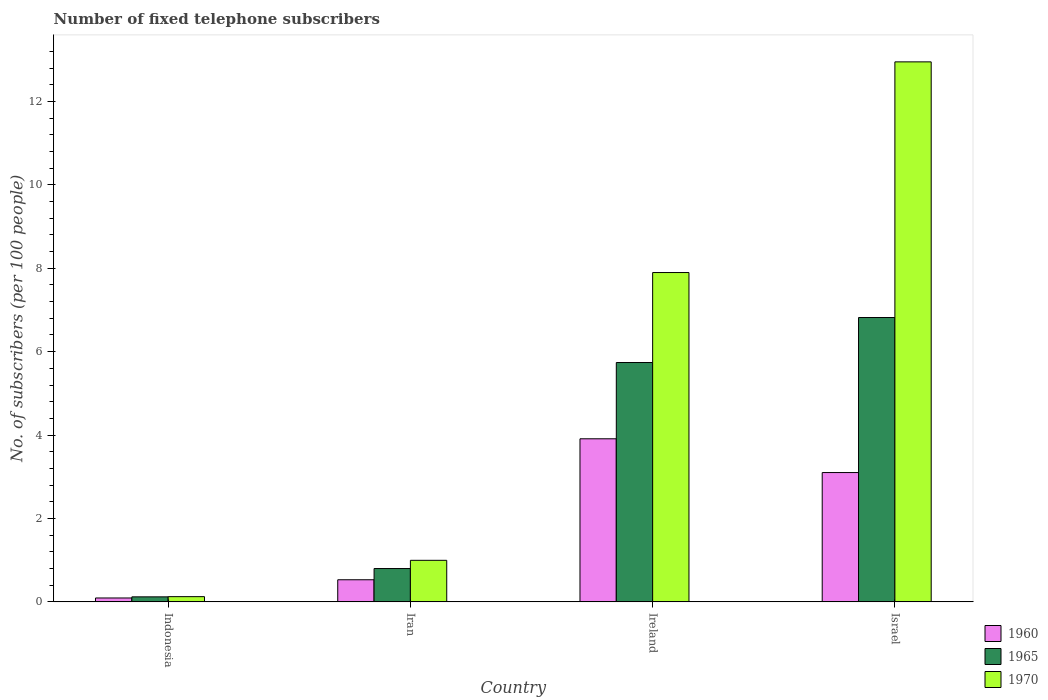How many groups of bars are there?
Provide a succinct answer. 4. How many bars are there on the 1st tick from the right?
Your answer should be very brief. 3. What is the label of the 3rd group of bars from the left?
Provide a succinct answer. Ireland. In how many cases, is the number of bars for a given country not equal to the number of legend labels?
Your answer should be very brief. 0. What is the number of fixed telephone subscribers in 1960 in Iran?
Your response must be concise. 0.53. Across all countries, what is the maximum number of fixed telephone subscribers in 1965?
Your answer should be compact. 6.82. Across all countries, what is the minimum number of fixed telephone subscribers in 1965?
Your answer should be compact. 0.12. In which country was the number of fixed telephone subscribers in 1960 maximum?
Offer a very short reply. Ireland. In which country was the number of fixed telephone subscribers in 1960 minimum?
Your response must be concise. Indonesia. What is the total number of fixed telephone subscribers in 1970 in the graph?
Your response must be concise. 21.97. What is the difference between the number of fixed telephone subscribers in 1960 in Indonesia and that in Iran?
Your answer should be very brief. -0.44. What is the difference between the number of fixed telephone subscribers in 1970 in Ireland and the number of fixed telephone subscribers in 1960 in Israel?
Your answer should be compact. 4.8. What is the average number of fixed telephone subscribers in 1960 per country?
Your answer should be compact. 1.91. What is the difference between the number of fixed telephone subscribers of/in 1960 and number of fixed telephone subscribers of/in 1970 in Iran?
Ensure brevity in your answer.  -0.47. In how many countries, is the number of fixed telephone subscribers in 1960 greater than 2?
Your answer should be very brief. 2. What is the ratio of the number of fixed telephone subscribers in 1960 in Ireland to that in Israel?
Give a very brief answer. 1.26. Is the number of fixed telephone subscribers in 1970 in Indonesia less than that in Israel?
Your answer should be compact. Yes. What is the difference between the highest and the second highest number of fixed telephone subscribers in 1965?
Keep it short and to the point. -4.94. What is the difference between the highest and the lowest number of fixed telephone subscribers in 1965?
Your answer should be very brief. 6.7. Is the sum of the number of fixed telephone subscribers in 1970 in Iran and Israel greater than the maximum number of fixed telephone subscribers in 1960 across all countries?
Your answer should be compact. Yes. What does the 1st bar from the left in Israel represents?
Keep it short and to the point. 1960. How many bars are there?
Your answer should be very brief. 12. How many countries are there in the graph?
Offer a terse response. 4. What is the difference between two consecutive major ticks on the Y-axis?
Ensure brevity in your answer.  2. Are the values on the major ticks of Y-axis written in scientific E-notation?
Give a very brief answer. No. Does the graph contain any zero values?
Give a very brief answer. No. Does the graph contain grids?
Give a very brief answer. No. Where does the legend appear in the graph?
Your answer should be very brief. Bottom right. How many legend labels are there?
Offer a terse response. 3. How are the legend labels stacked?
Provide a short and direct response. Vertical. What is the title of the graph?
Provide a short and direct response. Number of fixed telephone subscribers. What is the label or title of the X-axis?
Offer a terse response. Country. What is the label or title of the Y-axis?
Provide a succinct answer. No. of subscribers (per 100 people). What is the No. of subscribers (per 100 people) of 1960 in Indonesia?
Offer a terse response. 0.09. What is the No. of subscribers (per 100 people) in 1965 in Indonesia?
Your response must be concise. 0.12. What is the No. of subscribers (per 100 people) in 1970 in Indonesia?
Give a very brief answer. 0.13. What is the No. of subscribers (per 100 people) in 1960 in Iran?
Your answer should be compact. 0.53. What is the No. of subscribers (per 100 people) in 1965 in Iran?
Your response must be concise. 0.8. What is the No. of subscribers (per 100 people) of 1970 in Iran?
Offer a very short reply. 1. What is the No. of subscribers (per 100 people) in 1960 in Ireland?
Your response must be concise. 3.91. What is the No. of subscribers (per 100 people) of 1965 in Ireland?
Make the answer very short. 5.74. What is the No. of subscribers (per 100 people) in 1970 in Ireland?
Provide a succinct answer. 7.9. What is the No. of subscribers (per 100 people) in 1960 in Israel?
Ensure brevity in your answer.  3.1. What is the No. of subscribers (per 100 people) of 1965 in Israel?
Ensure brevity in your answer.  6.82. What is the No. of subscribers (per 100 people) in 1970 in Israel?
Make the answer very short. 12.95. Across all countries, what is the maximum No. of subscribers (per 100 people) of 1960?
Provide a short and direct response. 3.91. Across all countries, what is the maximum No. of subscribers (per 100 people) of 1965?
Give a very brief answer. 6.82. Across all countries, what is the maximum No. of subscribers (per 100 people) of 1970?
Your answer should be compact. 12.95. Across all countries, what is the minimum No. of subscribers (per 100 people) in 1960?
Provide a succinct answer. 0.09. Across all countries, what is the minimum No. of subscribers (per 100 people) of 1965?
Keep it short and to the point. 0.12. Across all countries, what is the minimum No. of subscribers (per 100 people) in 1970?
Make the answer very short. 0.13. What is the total No. of subscribers (per 100 people) in 1960 in the graph?
Keep it short and to the point. 7.64. What is the total No. of subscribers (per 100 people) in 1965 in the graph?
Give a very brief answer. 13.48. What is the total No. of subscribers (per 100 people) of 1970 in the graph?
Offer a terse response. 21.97. What is the difference between the No. of subscribers (per 100 people) in 1960 in Indonesia and that in Iran?
Ensure brevity in your answer.  -0.44. What is the difference between the No. of subscribers (per 100 people) of 1965 in Indonesia and that in Iran?
Provide a short and direct response. -0.68. What is the difference between the No. of subscribers (per 100 people) in 1970 in Indonesia and that in Iran?
Offer a terse response. -0.87. What is the difference between the No. of subscribers (per 100 people) of 1960 in Indonesia and that in Ireland?
Provide a short and direct response. -3.82. What is the difference between the No. of subscribers (per 100 people) in 1965 in Indonesia and that in Ireland?
Keep it short and to the point. -5.62. What is the difference between the No. of subscribers (per 100 people) in 1970 in Indonesia and that in Ireland?
Ensure brevity in your answer.  -7.77. What is the difference between the No. of subscribers (per 100 people) in 1960 in Indonesia and that in Israel?
Provide a short and direct response. -3.01. What is the difference between the No. of subscribers (per 100 people) in 1965 in Indonesia and that in Israel?
Your response must be concise. -6.7. What is the difference between the No. of subscribers (per 100 people) of 1970 in Indonesia and that in Israel?
Offer a very short reply. -12.82. What is the difference between the No. of subscribers (per 100 people) in 1960 in Iran and that in Ireland?
Your response must be concise. -3.38. What is the difference between the No. of subscribers (per 100 people) in 1965 in Iran and that in Ireland?
Provide a short and direct response. -4.94. What is the difference between the No. of subscribers (per 100 people) of 1970 in Iran and that in Ireland?
Keep it short and to the point. -6.9. What is the difference between the No. of subscribers (per 100 people) of 1960 in Iran and that in Israel?
Provide a short and direct response. -2.57. What is the difference between the No. of subscribers (per 100 people) in 1965 in Iran and that in Israel?
Provide a short and direct response. -6.02. What is the difference between the No. of subscribers (per 100 people) of 1970 in Iran and that in Israel?
Your answer should be very brief. -11.95. What is the difference between the No. of subscribers (per 100 people) in 1960 in Ireland and that in Israel?
Provide a short and direct response. 0.81. What is the difference between the No. of subscribers (per 100 people) in 1965 in Ireland and that in Israel?
Your answer should be very brief. -1.08. What is the difference between the No. of subscribers (per 100 people) in 1970 in Ireland and that in Israel?
Your response must be concise. -5.05. What is the difference between the No. of subscribers (per 100 people) in 1960 in Indonesia and the No. of subscribers (per 100 people) in 1965 in Iran?
Your answer should be very brief. -0.71. What is the difference between the No. of subscribers (per 100 people) in 1960 in Indonesia and the No. of subscribers (per 100 people) in 1970 in Iran?
Provide a succinct answer. -0.9. What is the difference between the No. of subscribers (per 100 people) in 1965 in Indonesia and the No. of subscribers (per 100 people) in 1970 in Iran?
Provide a short and direct response. -0.88. What is the difference between the No. of subscribers (per 100 people) of 1960 in Indonesia and the No. of subscribers (per 100 people) of 1965 in Ireland?
Offer a very short reply. -5.65. What is the difference between the No. of subscribers (per 100 people) of 1960 in Indonesia and the No. of subscribers (per 100 people) of 1970 in Ireland?
Make the answer very short. -7.8. What is the difference between the No. of subscribers (per 100 people) of 1965 in Indonesia and the No. of subscribers (per 100 people) of 1970 in Ireland?
Provide a succinct answer. -7.78. What is the difference between the No. of subscribers (per 100 people) of 1960 in Indonesia and the No. of subscribers (per 100 people) of 1965 in Israel?
Give a very brief answer. -6.73. What is the difference between the No. of subscribers (per 100 people) of 1960 in Indonesia and the No. of subscribers (per 100 people) of 1970 in Israel?
Your answer should be compact. -12.86. What is the difference between the No. of subscribers (per 100 people) of 1965 in Indonesia and the No. of subscribers (per 100 people) of 1970 in Israel?
Your response must be concise. -12.83. What is the difference between the No. of subscribers (per 100 people) in 1960 in Iran and the No. of subscribers (per 100 people) in 1965 in Ireland?
Your answer should be very brief. -5.21. What is the difference between the No. of subscribers (per 100 people) of 1960 in Iran and the No. of subscribers (per 100 people) of 1970 in Ireland?
Make the answer very short. -7.37. What is the difference between the No. of subscribers (per 100 people) of 1965 in Iran and the No. of subscribers (per 100 people) of 1970 in Ireland?
Provide a short and direct response. -7.1. What is the difference between the No. of subscribers (per 100 people) of 1960 in Iran and the No. of subscribers (per 100 people) of 1965 in Israel?
Provide a short and direct response. -6.29. What is the difference between the No. of subscribers (per 100 people) of 1960 in Iran and the No. of subscribers (per 100 people) of 1970 in Israel?
Your answer should be very brief. -12.42. What is the difference between the No. of subscribers (per 100 people) of 1965 in Iran and the No. of subscribers (per 100 people) of 1970 in Israel?
Your answer should be very brief. -12.15. What is the difference between the No. of subscribers (per 100 people) in 1960 in Ireland and the No. of subscribers (per 100 people) in 1965 in Israel?
Offer a terse response. -2.91. What is the difference between the No. of subscribers (per 100 people) in 1960 in Ireland and the No. of subscribers (per 100 people) in 1970 in Israel?
Offer a very short reply. -9.04. What is the difference between the No. of subscribers (per 100 people) in 1965 in Ireland and the No. of subscribers (per 100 people) in 1970 in Israel?
Make the answer very short. -7.21. What is the average No. of subscribers (per 100 people) of 1960 per country?
Provide a succinct answer. 1.91. What is the average No. of subscribers (per 100 people) of 1965 per country?
Give a very brief answer. 3.37. What is the average No. of subscribers (per 100 people) in 1970 per country?
Offer a very short reply. 5.49. What is the difference between the No. of subscribers (per 100 people) of 1960 and No. of subscribers (per 100 people) of 1965 in Indonesia?
Your answer should be very brief. -0.03. What is the difference between the No. of subscribers (per 100 people) of 1960 and No. of subscribers (per 100 people) of 1970 in Indonesia?
Your answer should be compact. -0.03. What is the difference between the No. of subscribers (per 100 people) in 1965 and No. of subscribers (per 100 people) in 1970 in Indonesia?
Keep it short and to the point. -0. What is the difference between the No. of subscribers (per 100 people) of 1960 and No. of subscribers (per 100 people) of 1965 in Iran?
Your answer should be compact. -0.27. What is the difference between the No. of subscribers (per 100 people) in 1960 and No. of subscribers (per 100 people) in 1970 in Iran?
Provide a short and direct response. -0.47. What is the difference between the No. of subscribers (per 100 people) in 1965 and No. of subscribers (per 100 people) in 1970 in Iran?
Offer a very short reply. -0.2. What is the difference between the No. of subscribers (per 100 people) in 1960 and No. of subscribers (per 100 people) in 1965 in Ireland?
Provide a short and direct response. -1.83. What is the difference between the No. of subscribers (per 100 people) in 1960 and No. of subscribers (per 100 people) in 1970 in Ireland?
Your response must be concise. -3.99. What is the difference between the No. of subscribers (per 100 people) of 1965 and No. of subscribers (per 100 people) of 1970 in Ireland?
Offer a very short reply. -2.16. What is the difference between the No. of subscribers (per 100 people) in 1960 and No. of subscribers (per 100 people) in 1965 in Israel?
Offer a terse response. -3.72. What is the difference between the No. of subscribers (per 100 people) of 1960 and No. of subscribers (per 100 people) of 1970 in Israel?
Offer a terse response. -9.85. What is the difference between the No. of subscribers (per 100 people) of 1965 and No. of subscribers (per 100 people) of 1970 in Israel?
Give a very brief answer. -6.13. What is the ratio of the No. of subscribers (per 100 people) of 1960 in Indonesia to that in Iran?
Provide a succinct answer. 0.18. What is the ratio of the No. of subscribers (per 100 people) in 1965 in Indonesia to that in Iran?
Offer a very short reply. 0.15. What is the ratio of the No. of subscribers (per 100 people) in 1970 in Indonesia to that in Iran?
Your response must be concise. 0.13. What is the ratio of the No. of subscribers (per 100 people) of 1960 in Indonesia to that in Ireland?
Provide a succinct answer. 0.02. What is the ratio of the No. of subscribers (per 100 people) of 1965 in Indonesia to that in Ireland?
Your answer should be very brief. 0.02. What is the ratio of the No. of subscribers (per 100 people) of 1970 in Indonesia to that in Ireland?
Provide a short and direct response. 0.02. What is the ratio of the No. of subscribers (per 100 people) of 1960 in Indonesia to that in Israel?
Your response must be concise. 0.03. What is the ratio of the No. of subscribers (per 100 people) in 1965 in Indonesia to that in Israel?
Your response must be concise. 0.02. What is the ratio of the No. of subscribers (per 100 people) in 1970 in Indonesia to that in Israel?
Ensure brevity in your answer.  0.01. What is the ratio of the No. of subscribers (per 100 people) in 1960 in Iran to that in Ireland?
Provide a short and direct response. 0.14. What is the ratio of the No. of subscribers (per 100 people) in 1965 in Iran to that in Ireland?
Provide a succinct answer. 0.14. What is the ratio of the No. of subscribers (per 100 people) in 1970 in Iran to that in Ireland?
Offer a very short reply. 0.13. What is the ratio of the No. of subscribers (per 100 people) of 1960 in Iran to that in Israel?
Ensure brevity in your answer.  0.17. What is the ratio of the No. of subscribers (per 100 people) of 1965 in Iran to that in Israel?
Your answer should be very brief. 0.12. What is the ratio of the No. of subscribers (per 100 people) of 1970 in Iran to that in Israel?
Provide a succinct answer. 0.08. What is the ratio of the No. of subscribers (per 100 people) in 1960 in Ireland to that in Israel?
Your response must be concise. 1.26. What is the ratio of the No. of subscribers (per 100 people) in 1965 in Ireland to that in Israel?
Give a very brief answer. 0.84. What is the ratio of the No. of subscribers (per 100 people) in 1970 in Ireland to that in Israel?
Provide a succinct answer. 0.61. What is the difference between the highest and the second highest No. of subscribers (per 100 people) in 1960?
Ensure brevity in your answer.  0.81. What is the difference between the highest and the second highest No. of subscribers (per 100 people) in 1965?
Keep it short and to the point. 1.08. What is the difference between the highest and the second highest No. of subscribers (per 100 people) in 1970?
Offer a terse response. 5.05. What is the difference between the highest and the lowest No. of subscribers (per 100 people) in 1960?
Provide a short and direct response. 3.82. What is the difference between the highest and the lowest No. of subscribers (per 100 people) of 1965?
Your answer should be very brief. 6.7. What is the difference between the highest and the lowest No. of subscribers (per 100 people) of 1970?
Keep it short and to the point. 12.82. 